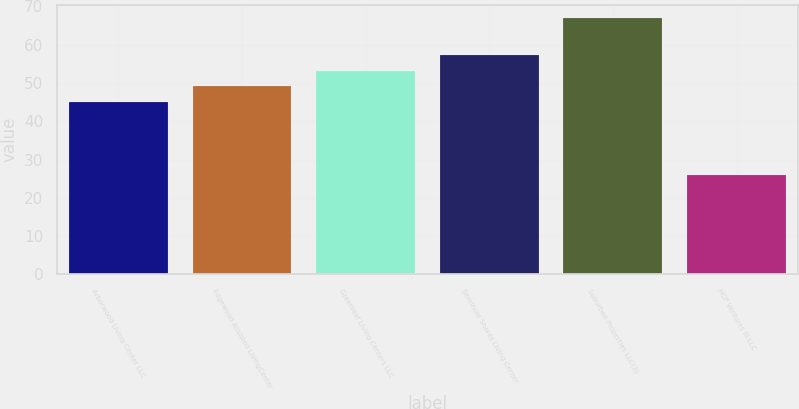<chart> <loc_0><loc_0><loc_500><loc_500><bar_chart><fcel>Arborwood Living Center LLC<fcel>Edgewood Assisted LivingCenter<fcel>Greenleaf Living Centers LLC<fcel>Seminole Shores Living Center<fcel>Suburban Properties LLC(3)<fcel>HCP Ventures III LLC<nl><fcel>45<fcel>49.1<fcel>53.2<fcel>57.3<fcel>67<fcel>26<nl></chart> 